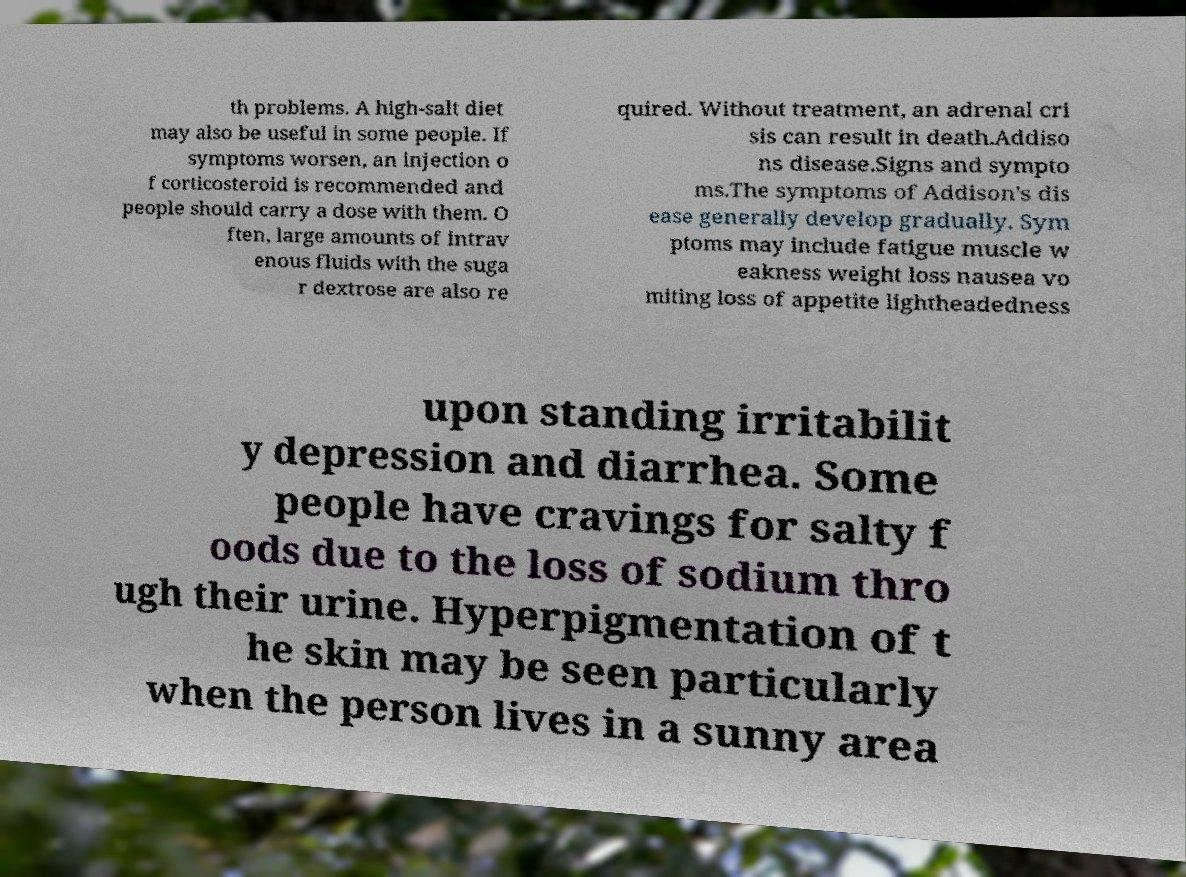Please identify and transcribe the text found in this image. th problems. A high-salt diet may also be useful in some people. If symptoms worsen, an injection o f corticosteroid is recommended and people should carry a dose with them. O ften, large amounts of intrav enous fluids with the suga r dextrose are also re quired. Without treatment, an adrenal cri sis can result in death.Addiso ns disease.Signs and sympto ms.The symptoms of Addison's dis ease generally develop gradually. Sym ptoms may include fatigue muscle w eakness weight loss nausea vo miting loss of appetite lightheadedness upon standing irritabilit y depression and diarrhea. Some people have cravings for salty f oods due to the loss of sodium thro ugh their urine. Hyperpigmentation of t he skin may be seen particularly when the person lives in a sunny area 